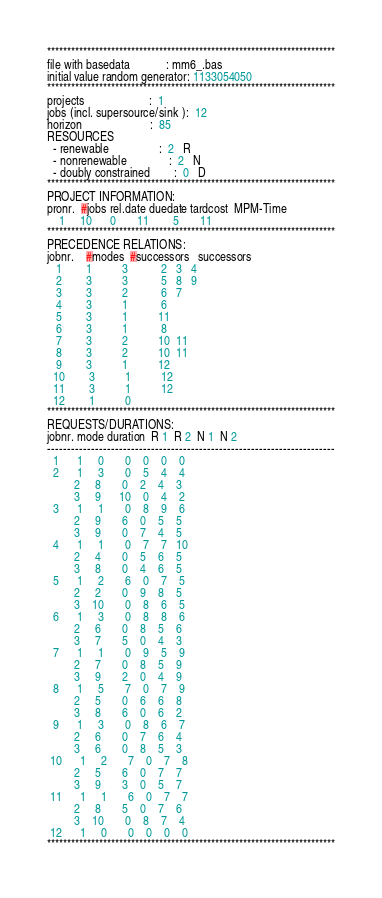<code> <loc_0><loc_0><loc_500><loc_500><_ObjectiveC_>************************************************************************
file with basedata            : mm6_.bas
initial value random generator: 1133054050
************************************************************************
projects                      :  1
jobs (incl. supersource/sink ):  12
horizon                       :  85
RESOURCES
  - renewable                 :  2   R
  - nonrenewable              :  2   N
  - doubly constrained        :  0   D
************************************************************************
PROJECT INFORMATION:
pronr.  #jobs rel.date duedate tardcost  MPM-Time
    1     10      0       11        5       11
************************************************************************
PRECEDENCE RELATIONS:
jobnr.    #modes  #successors   successors
   1        1          3           2   3   4
   2        3          3           5   8   9
   3        3          2           6   7
   4        3          1           6
   5        3          1          11
   6        3          1           8
   7        3          2          10  11
   8        3          2          10  11
   9        3          1          12
  10        3          1          12
  11        3          1          12
  12        1          0        
************************************************************************
REQUESTS/DURATIONS:
jobnr. mode duration  R 1  R 2  N 1  N 2
------------------------------------------------------------------------
  1      1     0       0    0    0    0
  2      1     3       0    5    4    4
         2     8       0    2    4    3
         3     9      10    0    4    2
  3      1     1       0    8    9    6
         2     9       6    0    5    5
         3     9       0    7    4    5
  4      1     1       0    7    7   10
         2     4       0    5    6    5
         3     8       0    4    6    5
  5      1     2       6    0    7    5
         2     2       0    9    8    5
         3    10       0    8    6    5
  6      1     3       0    8    8    6
         2     6       0    8    5    6
         3     7       5    0    4    3
  7      1     1       0    9    5    9
         2     7       0    8    5    9
         3     9       2    0    4    9
  8      1     5       7    0    7    9
         2     5       0    6    6    8
         3     8       6    0    6    2
  9      1     3       0    8    6    7
         2     6       0    7    6    4
         3     6       0    8    5    3
 10      1     2       7    0    7    8
         2     5       6    0    7    7
         3     9       3    0    5    7
 11      1     1       6    0    7    7
         2     8       5    0    7    6
         3    10       0    8    7    4
 12      1     0       0    0    0    0
************************************************************************</code> 